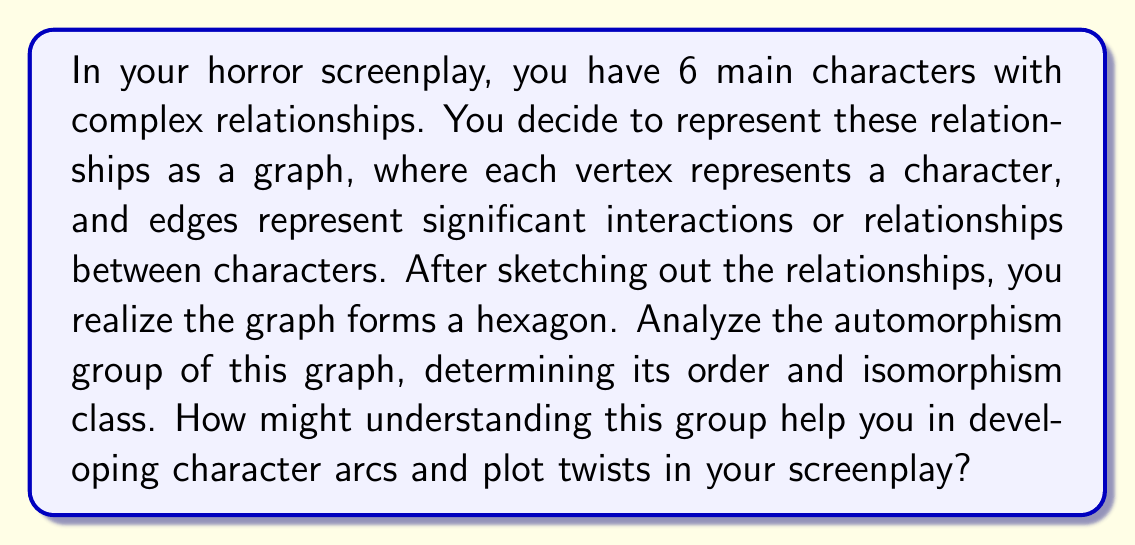Help me with this question. Let's approach this step-by-step:

1) First, we need to understand what the graph looks like. It's a hexagon, which means it has 6 vertices and 6 edges, forming a cyclic structure.

2) The automorphism group of a graph consists of all permutations of vertices that preserve adjacency. In other words, these are the symmetries of the graph.

3) For a hexagon, we have two types of symmetries:
   a) Rotations: There are 6 rotational symmetries (including the identity).
   b) Reflections: There are 6 reflection symmetries.

4) The total number of symmetries (order of the automorphism group) is thus 12.

5) This group is isomorphic to the dihedral group $D_6$ (also written as $D_{12}$ in some conventions).

6) The structure of $D_6$ can be described as:
   $$D_6 = \langle r, s | r^6 = s^2 = 1, srs = r^{-1} \rangle$$
   where $r$ represents a rotation and $s$ represents a reflection.

7) In terms of screenplay development:
   - The rotational symmetry suggests that the plot could have a cyclic nature, where events or character developments come full circle.
   - The reflection symmetry might inspire parallel storylines or character foils.
   - The order of the group (12) could suggest 12 major plot points or scene transitions.
   - The fact that $D_6$ is non-abelian could inspire complex, non-commutative interactions between characters.

8) Understanding this structure can help in creating balanced, symmetric storytelling while also providing opportunities for unexpected twists when the symmetry is broken.
Answer: The automorphism group of the hexagon graph is isomorphic to the dihedral group $D_6$, with order 12. This understanding can inspire cyclic plot structures, parallel storylines, and complex character interactions in the horror screenplay. 